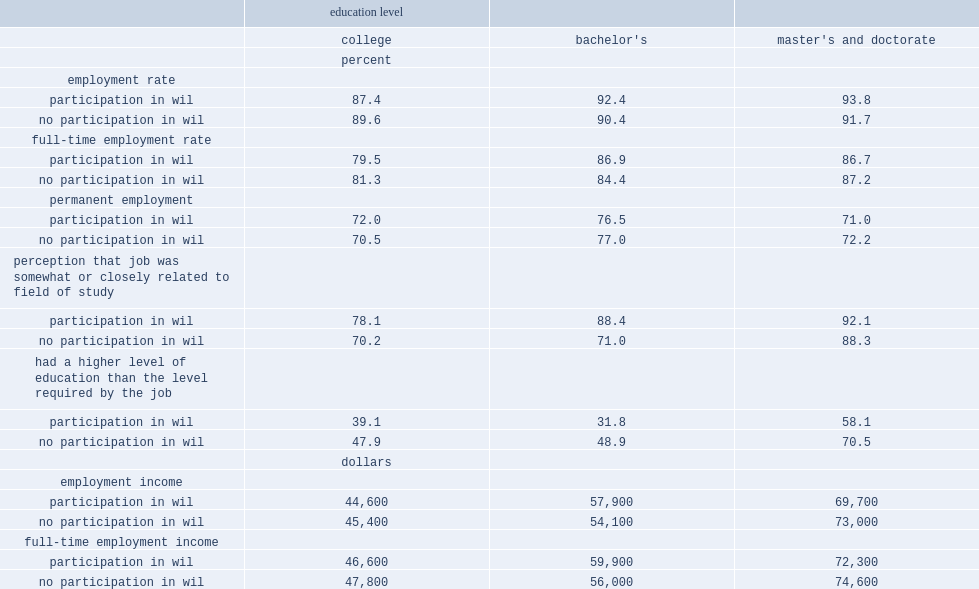What is the percentage of bachelor's graduates who participated in wil reported finding a job that they felt was related to their field of study? 88.4. What is the percentage of bachelor's graduates who did not participated in wil reported finding a job that they felt was related to their field of study? 71.0. What is the percentage of bachelor's graduates who participated in wil were less likely to be overqualified for their job? 31.8. What is the percentage of bachelor's graduates who did not participate in wil were less likely to be overqualified for their job? 48.9. 